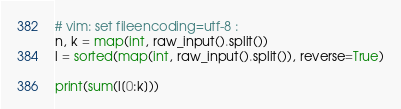<code> <loc_0><loc_0><loc_500><loc_500><_Python_># vim: set fileencoding=utf-8 :
n, k = map(int, raw_input().split())
l = sorted(map(int, raw_input().split()), reverse=True)

print(sum(l[0:k]))
</code> 